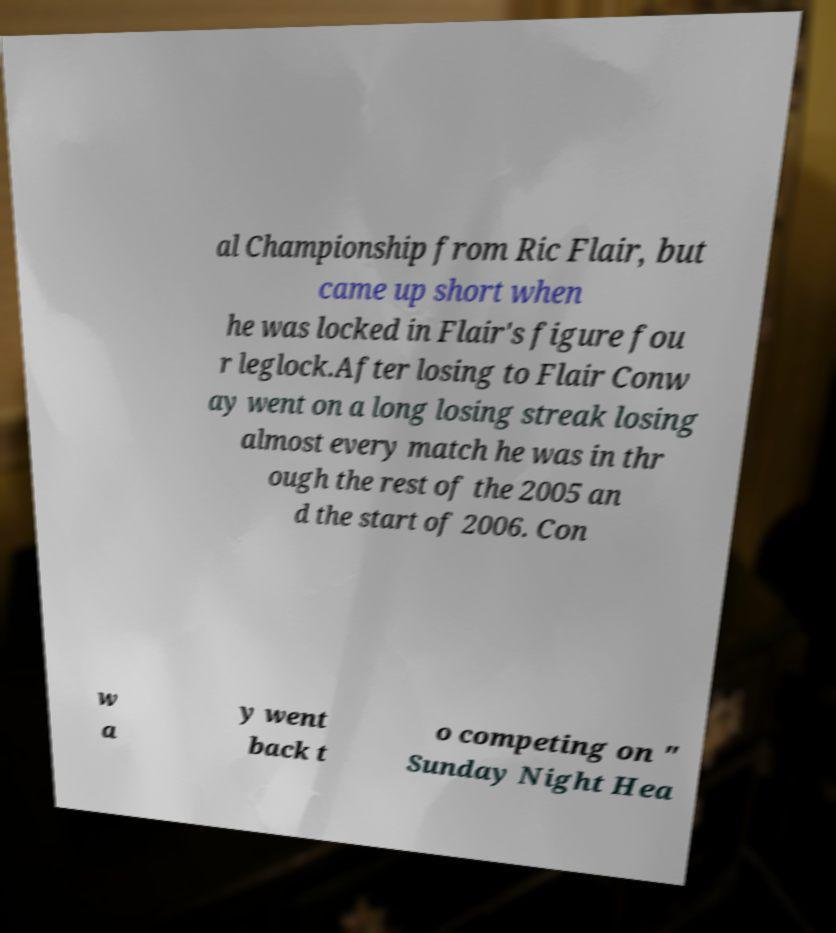Can you accurately transcribe the text from the provided image for me? al Championship from Ric Flair, but came up short when he was locked in Flair's figure fou r leglock.After losing to Flair Conw ay went on a long losing streak losing almost every match he was in thr ough the rest of the 2005 an d the start of 2006. Con w a y went back t o competing on " Sunday Night Hea 